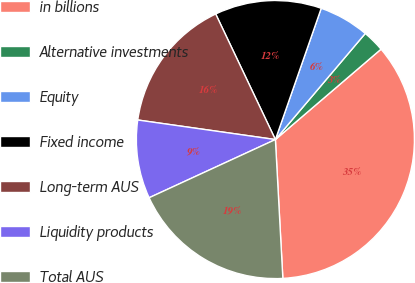<chart> <loc_0><loc_0><loc_500><loc_500><pie_chart><fcel>in billions<fcel>Alternative investments<fcel>Equity<fcel>Fixed income<fcel>Long-term AUS<fcel>Liquidity products<fcel>Total AUS<nl><fcel>35.41%<fcel>2.55%<fcel>5.84%<fcel>12.41%<fcel>15.69%<fcel>9.12%<fcel>18.98%<nl></chart> 